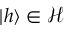Convert formula to latex. <formula><loc_0><loc_0><loc_500><loc_500>| h \rangle \in { \mathcal { H } }</formula> 